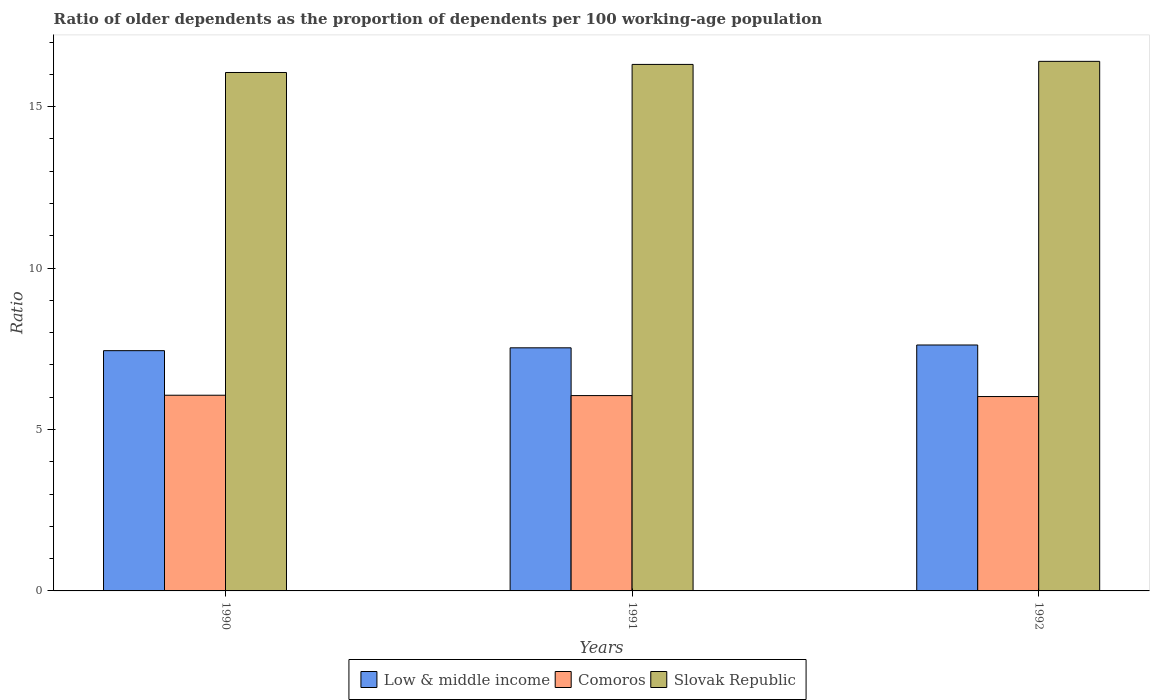How many different coloured bars are there?
Make the answer very short. 3. Are the number of bars per tick equal to the number of legend labels?
Offer a terse response. Yes. How many bars are there on the 3rd tick from the left?
Your response must be concise. 3. How many bars are there on the 1st tick from the right?
Your response must be concise. 3. In how many cases, is the number of bars for a given year not equal to the number of legend labels?
Keep it short and to the point. 0. What is the age dependency ratio(old) in Low & middle income in 1992?
Your answer should be very brief. 7.62. Across all years, what is the maximum age dependency ratio(old) in Low & middle income?
Ensure brevity in your answer.  7.62. Across all years, what is the minimum age dependency ratio(old) in Comoros?
Offer a very short reply. 6.02. In which year was the age dependency ratio(old) in Slovak Republic maximum?
Your answer should be compact. 1992. In which year was the age dependency ratio(old) in Low & middle income minimum?
Your response must be concise. 1990. What is the total age dependency ratio(old) in Low & middle income in the graph?
Ensure brevity in your answer.  22.59. What is the difference between the age dependency ratio(old) in Comoros in 1990 and that in 1991?
Your answer should be very brief. 0.01. What is the difference between the age dependency ratio(old) in Slovak Republic in 1991 and the age dependency ratio(old) in Comoros in 1990?
Ensure brevity in your answer.  10.25. What is the average age dependency ratio(old) in Slovak Republic per year?
Provide a short and direct response. 16.26. In the year 1992, what is the difference between the age dependency ratio(old) in Low & middle income and age dependency ratio(old) in Comoros?
Make the answer very short. 1.6. In how many years, is the age dependency ratio(old) in Low & middle income greater than 12?
Offer a very short reply. 0. What is the ratio of the age dependency ratio(old) in Low & middle income in 1990 to that in 1992?
Offer a terse response. 0.98. Is the difference between the age dependency ratio(old) in Low & middle income in 1990 and 1991 greater than the difference between the age dependency ratio(old) in Comoros in 1990 and 1991?
Provide a succinct answer. No. What is the difference between the highest and the second highest age dependency ratio(old) in Slovak Republic?
Make the answer very short. 0.09. What is the difference between the highest and the lowest age dependency ratio(old) in Low & middle income?
Your response must be concise. 0.18. In how many years, is the age dependency ratio(old) in Low & middle income greater than the average age dependency ratio(old) in Low & middle income taken over all years?
Make the answer very short. 2. What does the 3rd bar from the left in 1990 represents?
Offer a terse response. Slovak Republic. What does the 2nd bar from the right in 1992 represents?
Make the answer very short. Comoros. Is it the case that in every year, the sum of the age dependency ratio(old) in Comoros and age dependency ratio(old) in Slovak Republic is greater than the age dependency ratio(old) in Low & middle income?
Offer a very short reply. Yes. How many bars are there?
Your answer should be very brief. 9. Are all the bars in the graph horizontal?
Provide a succinct answer. No. What is the difference between two consecutive major ticks on the Y-axis?
Provide a succinct answer. 5. Are the values on the major ticks of Y-axis written in scientific E-notation?
Ensure brevity in your answer.  No. Does the graph contain any zero values?
Keep it short and to the point. No. Does the graph contain grids?
Make the answer very short. No. How many legend labels are there?
Provide a short and direct response. 3. How are the legend labels stacked?
Keep it short and to the point. Horizontal. What is the title of the graph?
Provide a short and direct response. Ratio of older dependents as the proportion of dependents per 100 working-age population. Does "Mali" appear as one of the legend labels in the graph?
Ensure brevity in your answer.  No. What is the label or title of the X-axis?
Offer a very short reply. Years. What is the label or title of the Y-axis?
Your response must be concise. Ratio. What is the Ratio of Low & middle income in 1990?
Provide a short and direct response. 7.44. What is the Ratio of Comoros in 1990?
Provide a succinct answer. 6.06. What is the Ratio of Slovak Republic in 1990?
Your answer should be compact. 16.06. What is the Ratio of Low & middle income in 1991?
Offer a very short reply. 7.53. What is the Ratio of Comoros in 1991?
Make the answer very short. 6.05. What is the Ratio of Slovak Republic in 1991?
Provide a short and direct response. 16.31. What is the Ratio of Low & middle income in 1992?
Offer a terse response. 7.62. What is the Ratio in Comoros in 1992?
Offer a very short reply. 6.02. What is the Ratio of Slovak Republic in 1992?
Offer a terse response. 16.4. Across all years, what is the maximum Ratio of Low & middle income?
Make the answer very short. 7.62. Across all years, what is the maximum Ratio of Comoros?
Give a very brief answer. 6.06. Across all years, what is the maximum Ratio of Slovak Republic?
Provide a succinct answer. 16.4. Across all years, what is the minimum Ratio in Low & middle income?
Make the answer very short. 7.44. Across all years, what is the minimum Ratio of Comoros?
Make the answer very short. 6.02. Across all years, what is the minimum Ratio of Slovak Republic?
Offer a very short reply. 16.06. What is the total Ratio of Low & middle income in the graph?
Give a very brief answer. 22.59. What is the total Ratio in Comoros in the graph?
Offer a terse response. 18.13. What is the total Ratio in Slovak Republic in the graph?
Offer a very short reply. 48.77. What is the difference between the Ratio in Low & middle income in 1990 and that in 1991?
Your response must be concise. -0.09. What is the difference between the Ratio in Comoros in 1990 and that in 1991?
Offer a very short reply. 0.01. What is the difference between the Ratio of Slovak Republic in 1990 and that in 1991?
Ensure brevity in your answer.  -0.25. What is the difference between the Ratio of Low & middle income in 1990 and that in 1992?
Offer a very short reply. -0.18. What is the difference between the Ratio in Comoros in 1990 and that in 1992?
Provide a short and direct response. 0.04. What is the difference between the Ratio in Slovak Republic in 1990 and that in 1992?
Offer a terse response. -0.34. What is the difference between the Ratio in Low & middle income in 1991 and that in 1992?
Provide a succinct answer. -0.09. What is the difference between the Ratio in Comoros in 1991 and that in 1992?
Provide a succinct answer. 0.03. What is the difference between the Ratio of Slovak Republic in 1991 and that in 1992?
Ensure brevity in your answer.  -0.09. What is the difference between the Ratio in Low & middle income in 1990 and the Ratio in Comoros in 1991?
Your answer should be very brief. 1.39. What is the difference between the Ratio of Low & middle income in 1990 and the Ratio of Slovak Republic in 1991?
Make the answer very short. -8.87. What is the difference between the Ratio in Comoros in 1990 and the Ratio in Slovak Republic in 1991?
Your answer should be compact. -10.25. What is the difference between the Ratio of Low & middle income in 1990 and the Ratio of Comoros in 1992?
Offer a terse response. 1.42. What is the difference between the Ratio of Low & middle income in 1990 and the Ratio of Slovak Republic in 1992?
Ensure brevity in your answer.  -8.96. What is the difference between the Ratio in Comoros in 1990 and the Ratio in Slovak Republic in 1992?
Ensure brevity in your answer.  -10.34. What is the difference between the Ratio in Low & middle income in 1991 and the Ratio in Comoros in 1992?
Give a very brief answer. 1.51. What is the difference between the Ratio in Low & middle income in 1991 and the Ratio in Slovak Republic in 1992?
Your answer should be very brief. -8.87. What is the difference between the Ratio of Comoros in 1991 and the Ratio of Slovak Republic in 1992?
Your response must be concise. -10.35. What is the average Ratio of Low & middle income per year?
Ensure brevity in your answer.  7.53. What is the average Ratio in Comoros per year?
Give a very brief answer. 6.04. What is the average Ratio of Slovak Republic per year?
Provide a short and direct response. 16.26. In the year 1990, what is the difference between the Ratio of Low & middle income and Ratio of Comoros?
Keep it short and to the point. 1.38. In the year 1990, what is the difference between the Ratio of Low & middle income and Ratio of Slovak Republic?
Keep it short and to the point. -8.62. In the year 1990, what is the difference between the Ratio in Comoros and Ratio in Slovak Republic?
Provide a succinct answer. -10. In the year 1991, what is the difference between the Ratio in Low & middle income and Ratio in Comoros?
Your answer should be very brief. 1.48. In the year 1991, what is the difference between the Ratio in Low & middle income and Ratio in Slovak Republic?
Your answer should be compact. -8.78. In the year 1991, what is the difference between the Ratio of Comoros and Ratio of Slovak Republic?
Your response must be concise. -10.26. In the year 1992, what is the difference between the Ratio of Low & middle income and Ratio of Comoros?
Make the answer very short. 1.6. In the year 1992, what is the difference between the Ratio of Low & middle income and Ratio of Slovak Republic?
Your answer should be compact. -8.79. In the year 1992, what is the difference between the Ratio of Comoros and Ratio of Slovak Republic?
Give a very brief answer. -10.38. What is the ratio of the Ratio in Low & middle income in 1990 to that in 1991?
Keep it short and to the point. 0.99. What is the ratio of the Ratio in Comoros in 1990 to that in 1991?
Your answer should be very brief. 1. What is the ratio of the Ratio in Slovak Republic in 1990 to that in 1991?
Provide a short and direct response. 0.98. What is the ratio of the Ratio in Low & middle income in 1990 to that in 1992?
Provide a short and direct response. 0.98. What is the ratio of the Ratio in Comoros in 1990 to that in 1992?
Provide a short and direct response. 1.01. What is the ratio of the Ratio in Slovak Republic in 1990 to that in 1992?
Offer a terse response. 0.98. What is the difference between the highest and the second highest Ratio of Low & middle income?
Your answer should be very brief. 0.09. What is the difference between the highest and the second highest Ratio of Comoros?
Ensure brevity in your answer.  0.01. What is the difference between the highest and the second highest Ratio in Slovak Republic?
Give a very brief answer. 0.09. What is the difference between the highest and the lowest Ratio of Low & middle income?
Your answer should be very brief. 0.18. What is the difference between the highest and the lowest Ratio in Comoros?
Provide a succinct answer. 0.04. What is the difference between the highest and the lowest Ratio in Slovak Republic?
Your response must be concise. 0.34. 